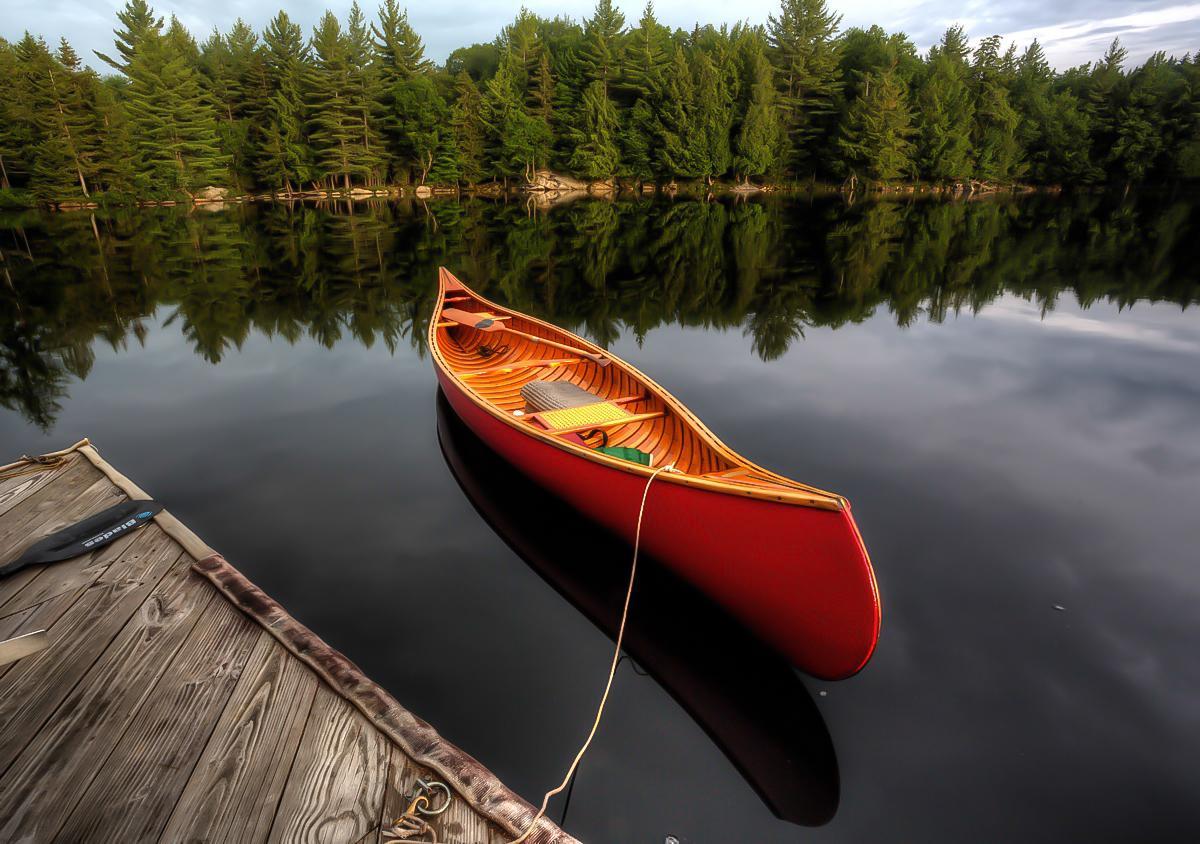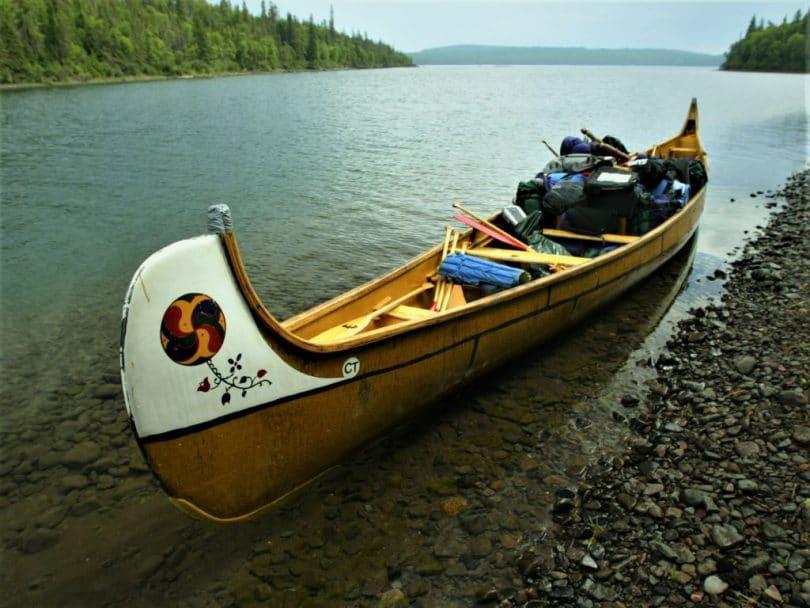The first image is the image on the left, the second image is the image on the right. For the images displayed, is the sentence "Each image shows in the foreground a boat containing gear pulled up to the water's edge so it is partly on ground." factually correct? Answer yes or no. No. The first image is the image on the left, the second image is the image on the right. Evaluate the accuracy of this statement regarding the images: "At least one person is sitting in a canoe in the image on the right.". Is it true? Answer yes or no. No. 